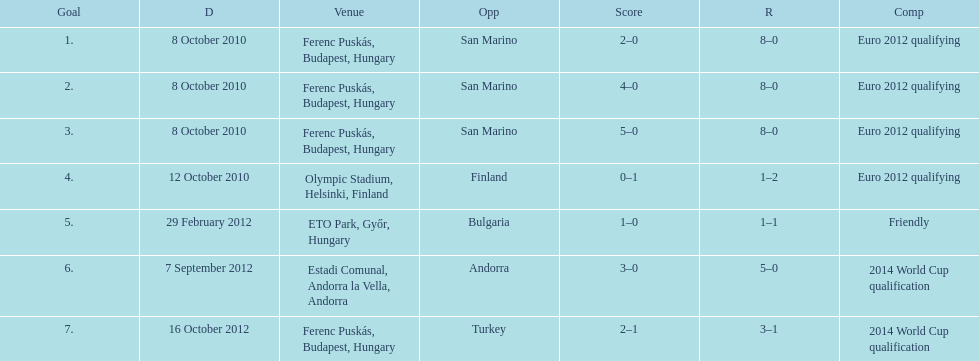When did ádám szalai make his first international goal? 8 October 2010. 